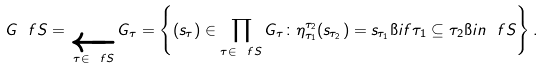<formula> <loc_0><loc_0><loc_500><loc_500>G _ { \ } f S = \underset { \tau \in \ f S } { \underleftarrow { \lim } } G _ { \tau } = \left \{ ( s _ { \tau } ) \in \prod _ { \tau \in \ f S } G _ { \tau } \colon \eta ^ { \tau _ { 2 } } _ { \tau _ { 1 } } ( s _ { \tau _ { 2 } } ) = s _ { \tau _ { 1 } } \i i f \tau _ { 1 } \subseteq \tau _ { 2 } \i i n \ f S \right \} .</formula> 